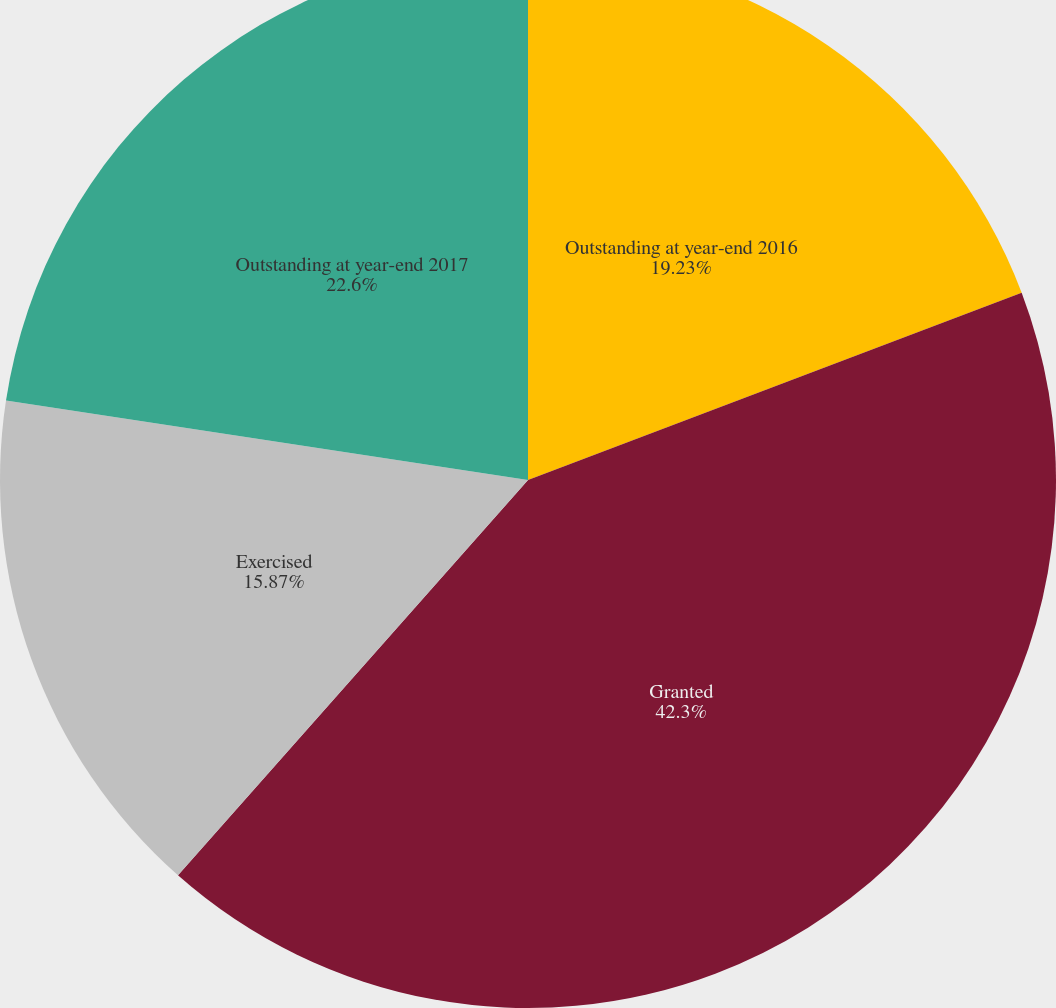Convert chart to OTSL. <chart><loc_0><loc_0><loc_500><loc_500><pie_chart><fcel>Outstanding at year-end 2016<fcel>Granted<fcel>Exercised<fcel>Outstanding at year-end 2017<nl><fcel>19.23%<fcel>42.31%<fcel>15.87%<fcel>22.6%<nl></chart> 